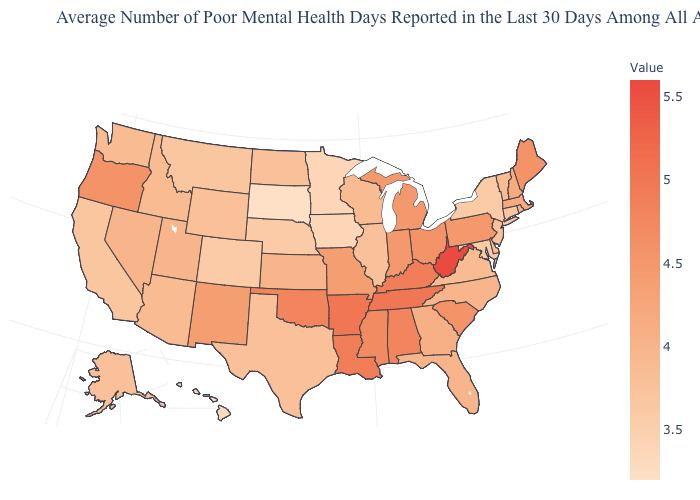Among the states that border Nebraska , does Missouri have the highest value?
Give a very brief answer. Yes. Which states have the highest value in the USA?
Short answer required. West Virginia. Does North Carolina have a higher value than Pennsylvania?
Concise answer only. No. Among the states that border Maryland , which have the lowest value?
Short answer required. Delaware, Virginia. 